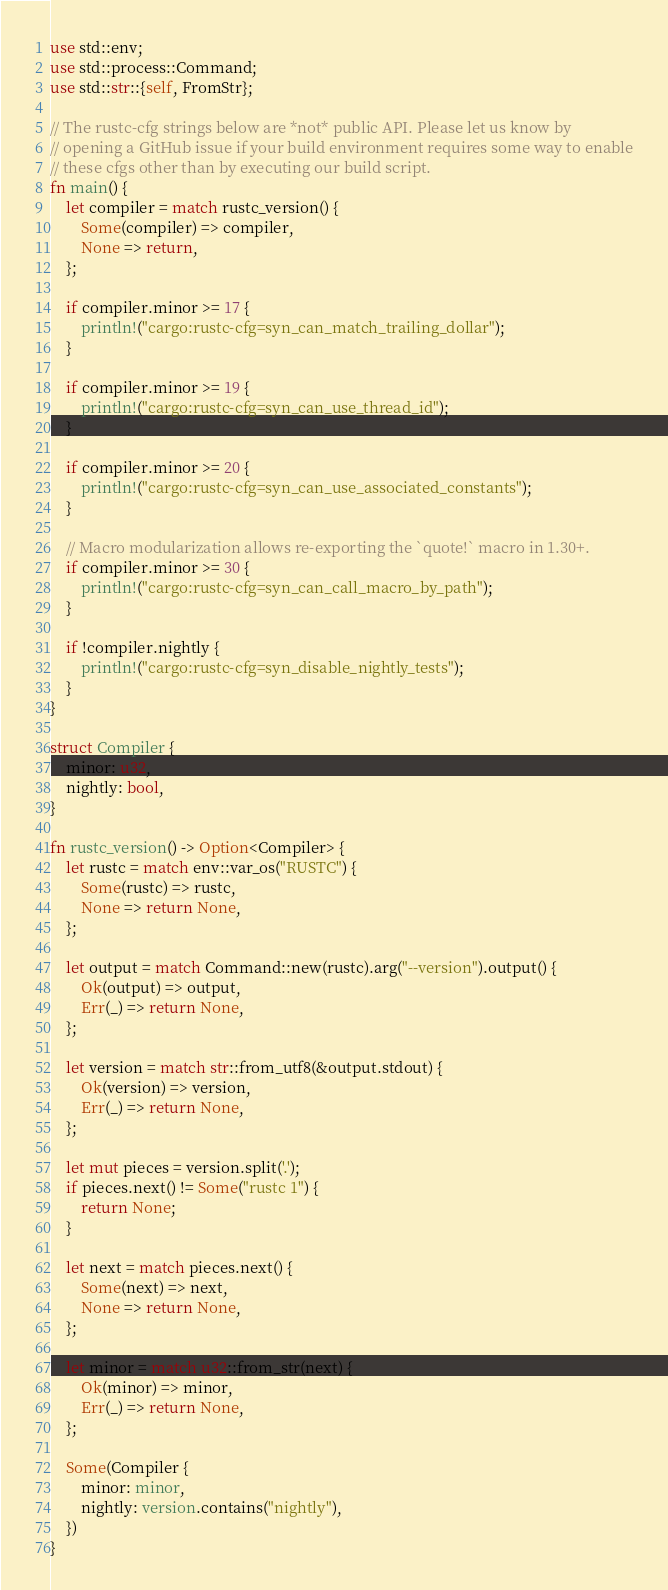<code> <loc_0><loc_0><loc_500><loc_500><_Rust_>use std::env;
use std::process::Command;
use std::str::{self, FromStr};

// The rustc-cfg strings below are *not* public API. Please let us know by
// opening a GitHub issue if your build environment requires some way to enable
// these cfgs other than by executing our build script.
fn main() {
    let compiler = match rustc_version() {
        Some(compiler) => compiler,
        None => return,
    };

    if compiler.minor >= 17 {
        println!("cargo:rustc-cfg=syn_can_match_trailing_dollar");
    }

    if compiler.minor >= 19 {
        println!("cargo:rustc-cfg=syn_can_use_thread_id");
    }

    if compiler.minor >= 20 {
        println!("cargo:rustc-cfg=syn_can_use_associated_constants");
    }

    // Macro modularization allows re-exporting the `quote!` macro in 1.30+.
    if compiler.minor >= 30 {
        println!("cargo:rustc-cfg=syn_can_call_macro_by_path");
    }

    if !compiler.nightly {
        println!("cargo:rustc-cfg=syn_disable_nightly_tests");
    }
}

struct Compiler {
    minor: u32,
    nightly: bool,
}

fn rustc_version() -> Option<Compiler> {
    let rustc = match env::var_os("RUSTC") {
        Some(rustc) => rustc,
        None => return None,
    };

    let output = match Command::new(rustc).arg("--version").output() {
        Ok(output) => output,
        Err(_) => return None,
    };

    let version = match str::from_utf8(&output.stdout) {
        Ok(version) => version,
        Err(_) => return None,
    };

    let mut pieces = version.split('.');
    if pieces.next() != Some("rustc 1") {
        return None;
    }

    let next = match pieces.next() {
        Some(next) => next,
        None => return None,
    };

    let minor = match u32::from_str(next) {
        Ok(minor) => minor,
        Err(_) => return None,
    };

    Some(Compiler {
        minor: minor,
        nightly: version.contains("nightly"),
    })
}
</code> 